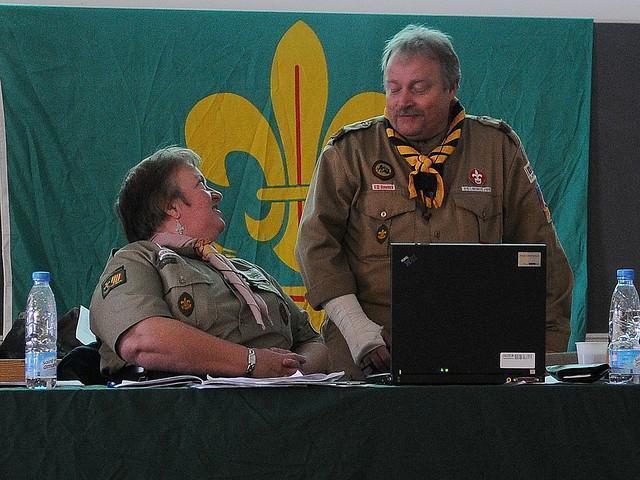How many bottles are in the photo?
Give a very brief answer. 2. How many people are in the picture?
Give a very brief answer. 2. How many cats are there?
Give a very brief answer. 0. 